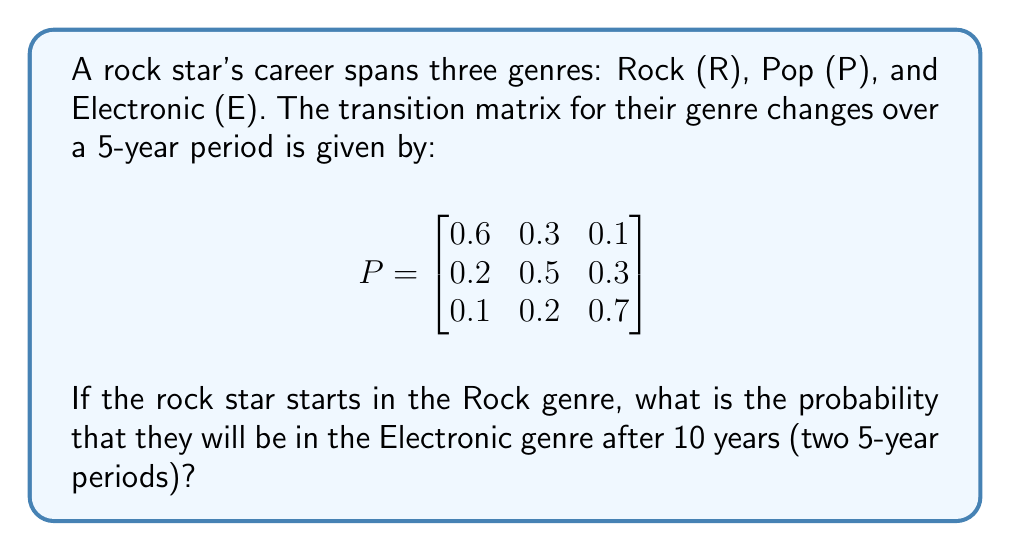Can you answer this question? To solve this problem, we need to use the Chapman-Kolmogorov equations and calculate the two-step transition probability.

Step 1: We need to calculate $P^2$, which represents the transition probabilities after 10 years (two 5-year periods).

$$P^2 = P \times P = \begin{bmatrix}
0.6 & 0.3 & 0.1 \\
0.2 & 0.5 & 0.3 \\
0.1 & 0.2 & 0.7
\end{bmatrix} \times \begin{bmatrix}
0.6 & 0.3 & 0.1 \\
0.2 & 0.5 & 0.3 \\
0.1 & 0.2 & 0.7
\end{bmatrix}$$

Step 2: Perform matrix multiplication:

$$P^2 = \begin{bmatrix}
(0.6)(0.6) + (0.3)(0.2) + (0.1)(0.1) & (0.6)(0.3) + (0.3)(0.5) + (0.1)(0.2) & (0.6)(0.1) + (0.3)(0.3) + (0.1)(0.7) \\
(0.2)(0.6) + (0.5)(0.2) + (0.3)(0.1) & (0.2)(0.3) + (0.5)(0.5) + (0.3)(0.2) & (0.2)(0.1) + (0.5)(0.3) + (0.3)(0.7) \\
(0.1)(0.6) + (0.2)(0.2) + (0.7)(0.1) & (0.1)(0.3) + (0.2)(0.5) + (0.7)(0.2) & (0.1)(0.1) + (0.2)(0.3) + (0.7)(0.7)
\end{bmatrix}$$

Step 3: Calculate the entries:

$$P^2 = \begin{bmatrix}
0.43 & 0.39 & 0.18 \\
0.25 & 0.41 & 0.34 \\
0.15 & 0.27 & 0.58
\end{bmatrix}$$

Step 4: The probability of transitioning from Rock (R) to Electronic (E) after 10 years is given by the entry in the first row, third column of $P^2$, which is 0.18.
Answer: 0.18 